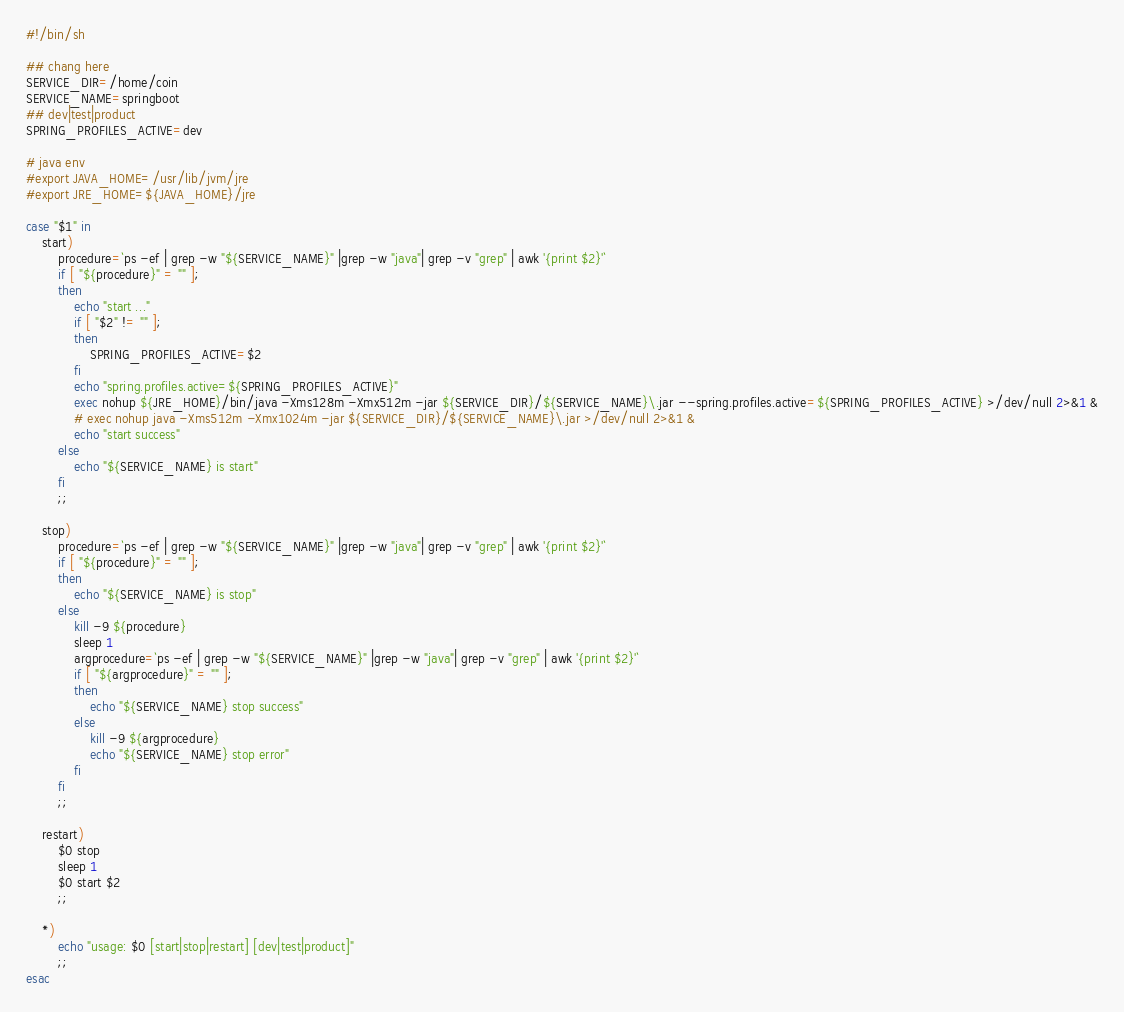<code> <loc_0><loc_0><loc_500><loc_500><_Bash_>#!/bin/sh

## chang here
SERVICE_DIR=/home/coin
SERVICE_NAME=springboot
## dev|test|product
SPRING_PROFILES_ACTIVE=dev

# java env
#export JAVA_HOME=/usr/lib/jvm/jre
#export JRE_HOME=${JAVA_HOME}/jre

case "$1" in 
	start)
		procedure=`ps -ef | grep -w "${SERVICE_NAME}" |grep -w "java"| grep -v "grep" | awk '{print $2}'`
		if [ "${procedure}" = "" ];
		then
			echo "start ..."
			if [ "$2" != "" ];
			then
				SPRING_PROFILES_ACTIVE=$2
			fi
			echo "spring.profiles.active=${SPRING_PROFILES_ACTIVE}"
			exec nohup ${JRE_HOME}/bin/java -Xms128m -Xmx512m -jar ${SERVICE_DIR}/${SERVICE_NAME}\.jar --spring.profiles.active=${SPRING_PROFILES_ACTIVE} >/dev/null 2>&1 &
			# exec nohup java -Xms512m -Xmx1024m -jar ${SERVICE_DIR}/${SERVICE_NAME}\.jar >/dev/null 2>&1 &
			echo "start success"
		else
			echo "${SERVICE_NAME} is start"
		fi
		;;
		
	stop)
		procedure=`ps -ef | grep -w "${SERVICE_NAME}" |grep -w "java"| grep -v "grep" | awk '{print $2}'`
		if [ "${procedure}" = "" ];
		then
			echo "${SERVICE_NAME} is stop"
		else
			kill -9 ${procedure}
			sleep 1
			argprocedure=`ps -ef | grep -w "${SERVICE_NAME}" |grep -w "java"| grep -v "grep" | awk '{print $2}'`
			if [ "${argprocedure}" = "" ];
			then
				echo "${SERVICE_NAME} stop success"
			else
				kill -9 ${argprocedure}
				echo "${SERVICE_NAME} stop error"
			fi
		fi
		;;
		
	restart)
		$0 stop
		sleep 1
		$0 start $2
		;;  
		
	*)
		echo "usage: $0 [start|stop|restart] [dev|test|product]"
		;;  
esac

</code> 